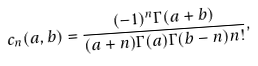<formula> <loc_0><loc_0><loc_500><loc_500>c _ { n } ( a , b ) = \frac { ( - 1 ) ^ { n } \Gamma ( a + b ) } { ( a + n ) \Gamma ( a ) \Gamma ( b - n ) n ! } ,</formula> 